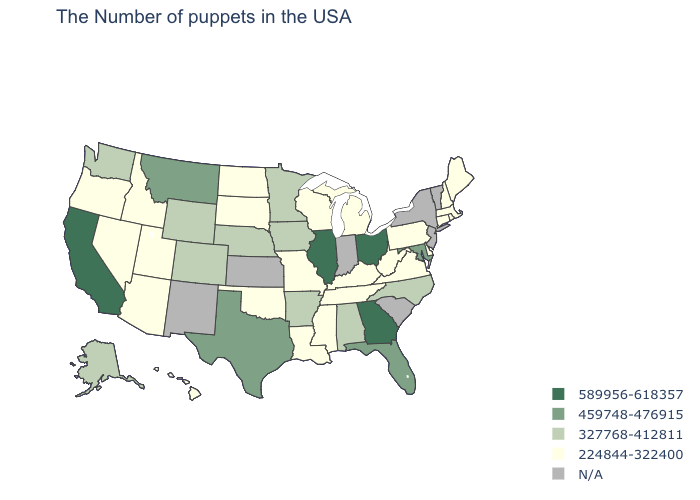What is the lowest value in the USA?
Concise answer only. 224844-322400. Name the states that have a value in the range 327768-412811?
Answer briefly. North Carolina, Alabama, Arkansas, Minnesota, Iowa, Nebraska, Wyoming, Colorado, Washington, Alaska. Does the map have missing data?
Answer briefly. Yes. What is the lowest value in the USA?
Keep it brief. 224844-322400. What is the highest value in states that border Rhode Island?
Give a very brief answer. 224844-322400. Does Illinois have the highest value in the USA?
Concise answer only. Yes. What is the highest value in the USA?
Write a very short answer. 589956-618357. How many symbols are there in the legend?
Write a very short answer. 5. Name the states that have a value in the range 327768-412811?
Be succinct. North Carolina, Alabama, Arkansas, Minnesota, Iowa, Nebraska, Wyoming, Colorado, Washington, Alaska. Which states have the lowest value in the MidWest?
Short answer required. Michigan, Wisconsin, Missouri, South Dakota, North Dakota. What is the highest value in states that border Colorado?
Quick response, please. 327768-412811. Which states have the lowest value in the USA?
Quick response, please. Maine, Massachusetts, Rhode Island, New Hampshire, Connecticut, Delaware, Pennsylvania, Virginia, West Virginia, Michigan, Kentucky, Tennessee, Wisconsin, Mississippi, Louisiana, Missouri, Oklahoma, South Dakota, North Dakota, Utah, Arizona, Idaho, Nevada, Oregon, Hawaii. Does Illinois have the highest value in the MidWest?
Be succinct. Yes. 